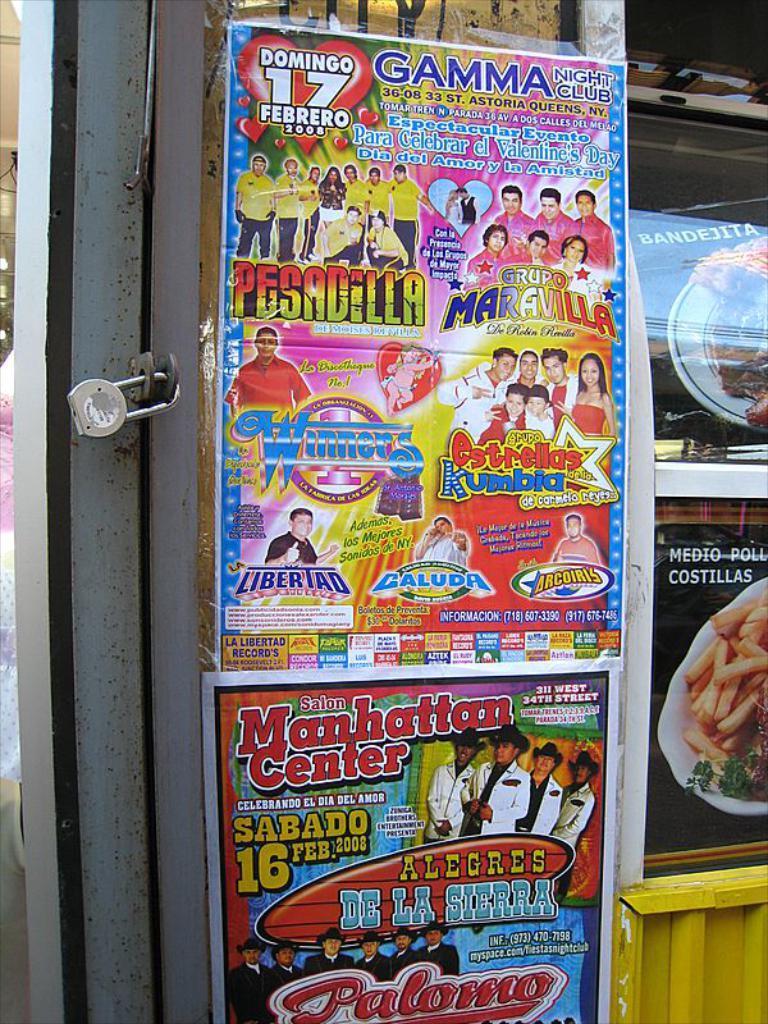Please provide a concise description of this image. In this picture we can see a lock, posters and some objects. On these posters we can see some people, food items and some text. 